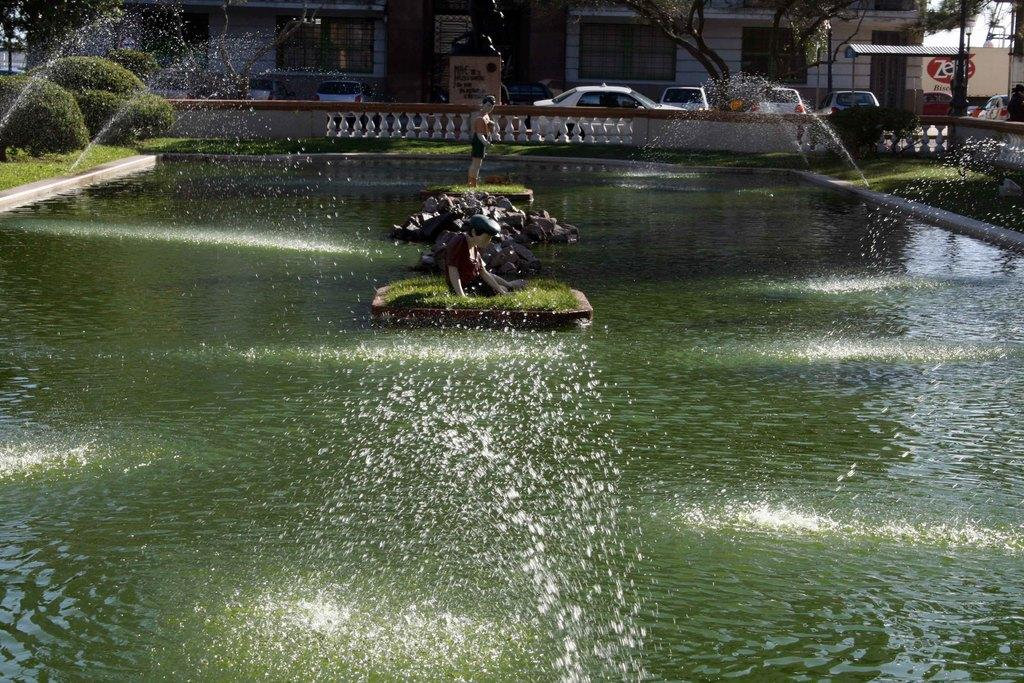What type of structures can be seen in the image? There are buildings and a shed in the image. What can be found on the floor in the image? Motor vehicles are present on the floor. What type of water feature is visible in the image? Fountains are visible in the image. What type of vegetation is present in the image? Bushes, trees, and grass are visible in the image. What type of artwork is present in the image? There are statues in the image. What type of material is present on the ground in the image? Stones are present in the image. What part of the natural environment is visible in the image? The sky is visible in the image. How does the image depict the concept of good-bye? The image does not depict the concept of good-bye; it features buildings, a shed, motor vehicles, fountains, bushes, trees, grass, statues, and stones. What type of hill is visible in the image? There is no hill present in the image. 